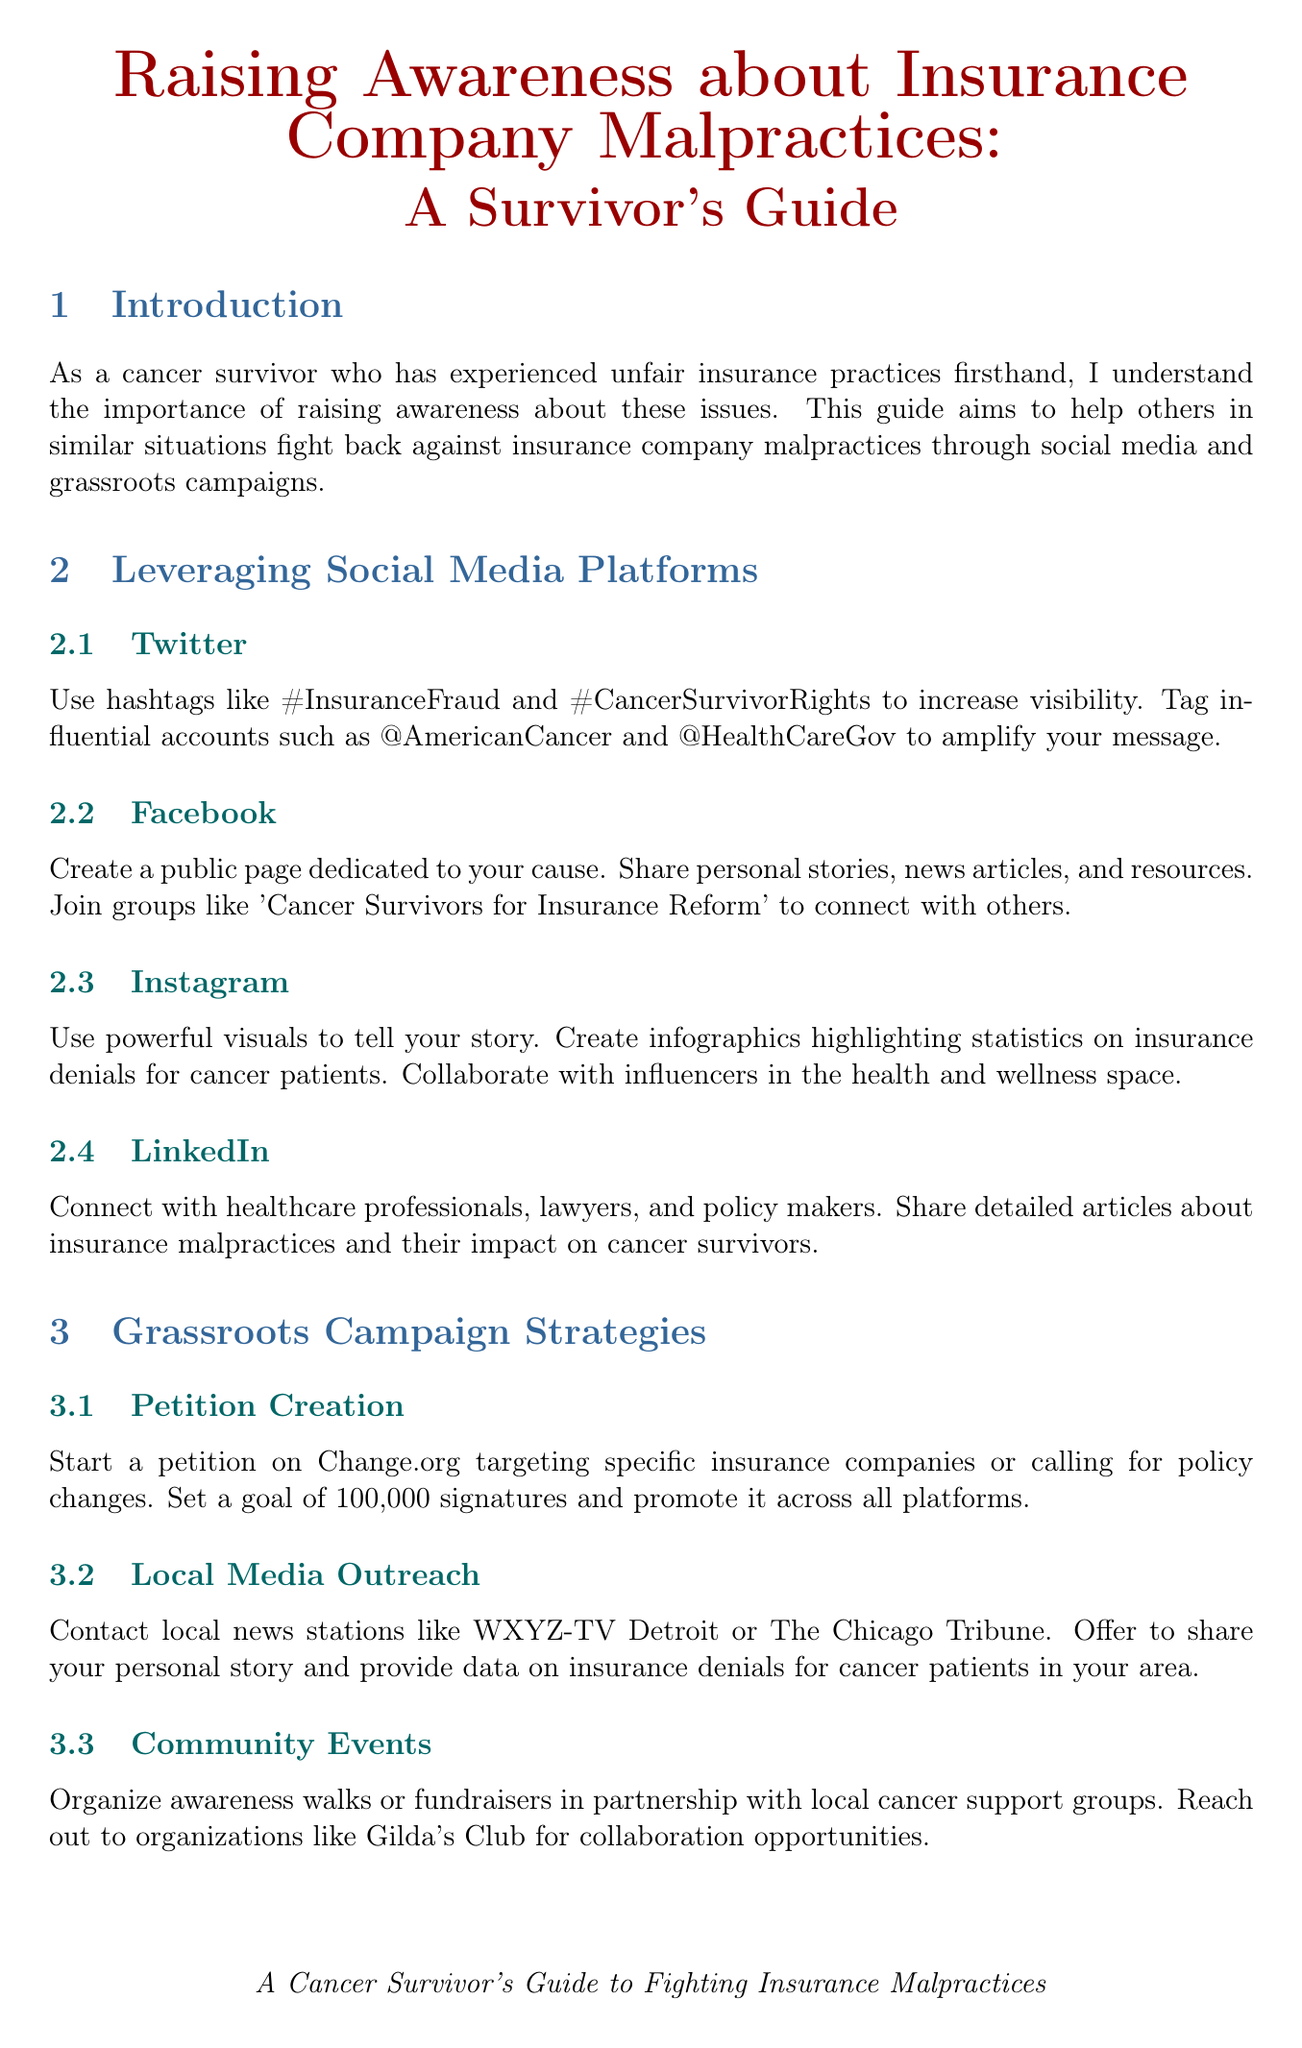What is the title of the guide? The title of the guide is stated at the beginning of the document.
Answer: Raising Awareness about Insurance Company Malpractices: A Survivor's Guide How many social media platforms are mentioned? The document lists four social media platforms in the "Leveraging Social Media Platforms" section.
Answer: Four What hashtag is suggested for increasing visibility on Twitter? The document specifies hashtags that can be used on Twitter.
Answer: #InsuranceFraud What is the goal for signatures in petition creation? The document outlines a specific target for the petition signatures in the grassroots campaign strategies.
Answer: 100,000 signatures Who should be contacted for local media outreach? The document provides examples of local news stations to contact regarding media outreach.
Answer: WXYZ-TV Detroit Which organization is mentioned for legal support? The document lists specific law firms specializing in insurance cases under the "Legal Support" subsection.
Answer: Kantor & Kantor LLP What is a potential name for a video series suggested in the document? The document gives a creative title for a proposed video series related to fighting insurance battles.
Answer: Cancer Survivor's Guide to Insurance Battles What type of feedback should be gathered regularly? The document advises on the nature of feedback to collect to enhance campaign effectiveness.
Answer: Feedback from supporters 